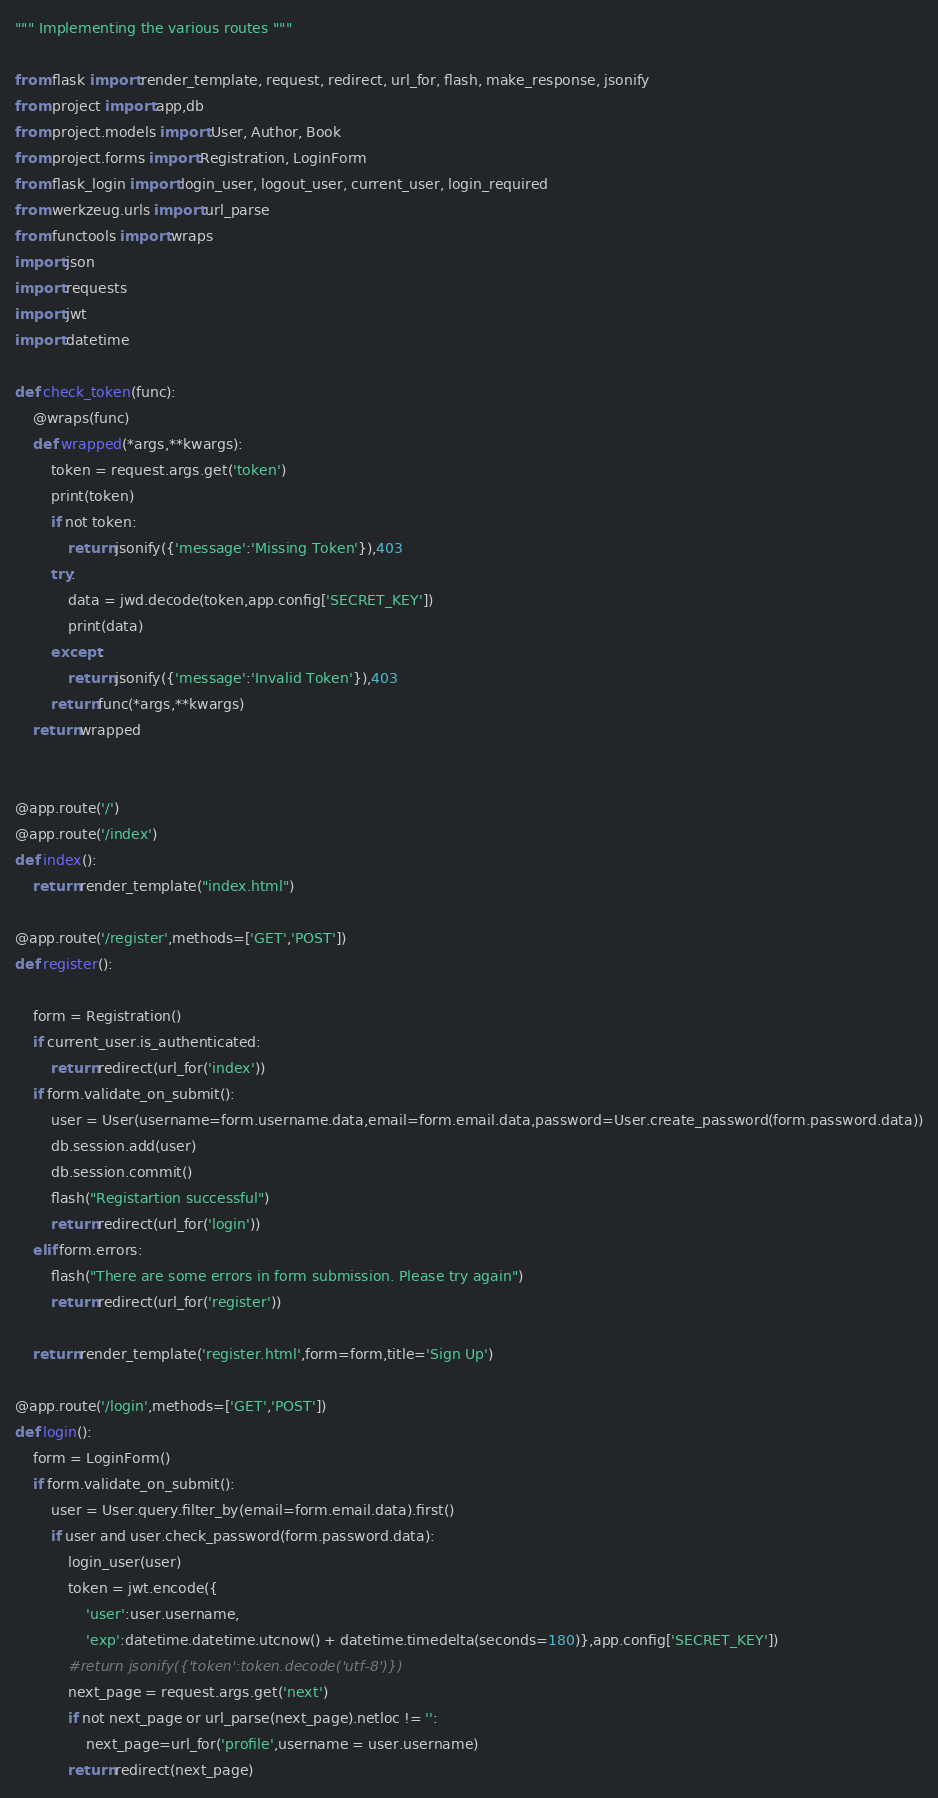<code> <loc_0><loc_0><loc_500><loc_500><_Python_>""" Implementing the various routes """

from flask import render_template, request, redirect, url_for, flash, make_response, jsonify
from project import app,db
from project.models import User, Author, Book
from project.forms import Registration, LoginForm
from flask_login import login_user, logout_user, current_user, login_required
from werkzeug.urls import url_parse
from functools import wraps
import json
import requests
import jwt
import datetime

def check_token(func):
    @wraps(func)
    def wrapped(*args,**kwargs):
        token = request.args.get('token')
        print(token)
        if not token:
            return jsonify({'message':'Missing Token'}),403
        try:
            data = jwd.decode(token,app.config['SECRET_KEY'])
            print(data)
        except:
            return jsonify({'message':'Invalid Token'}),403
        return func(*args,**kwargs)
    return wrapped 


@app.route('/')
@app.route('/index')
def index():
    return render_template("index.html")

@app.route('/register',methods=['GET','POST'])
def register():
    
    form = Registration()
    if current_user.is_authenticated:
        return redirect(url_for('index'))
    if form.validate_on_submit():
        user = User(username=form.username.data,email=form.email.data,password=User.create_password(form.password.data))
        db.session.add(user)
        db.session.commit()
        flash("Registartion successful")
        return redirect(url_for('login'))
    elif form.errors:
        flash("There are some errors in form submission. Please try again")
        return redirect(url_for('register'))

    return render_template('register.html',form=form,title='Sign Up')

@app.route('/login',methods=['GET','POST'])
def login():
    form = LoginForm()
    if form.validate_on_submit():
        user = User.query.filter_by(email=form.email.data).first()
        if user and user.check_password(form.password.data):
            login_user(user)
            token = jwt.encode({
                'user':user.username,
                'exp':datetime.datetime.utcnow() + datetime.timedelta(seconds=180)},app.config['SECRET_KEY'])
            #return jsonify({'token':token.decode('utf-8')})
            next_page = request.args.get('next')
            if not next_page or url_parse(next_page).netloc != '':
                next_page=url_for('profile',username = user.username)
            return redirect(next_page)</code> 